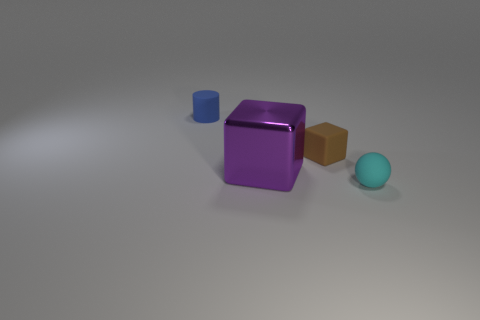Add 4 purple objects. How many objects exist? 8 Subtract all balls. How many objects are left? 3 Subtract all large metallic objects. Subtract all big cubes. How many objects are left? 2 Add 1 tiny matte cylinders. How many tiny matte cylinders are left? 2 Add 4 matte blocks. How many matte blocks exist? 5 Subtract 0 yellow cylinders. How many objects are left? 4 